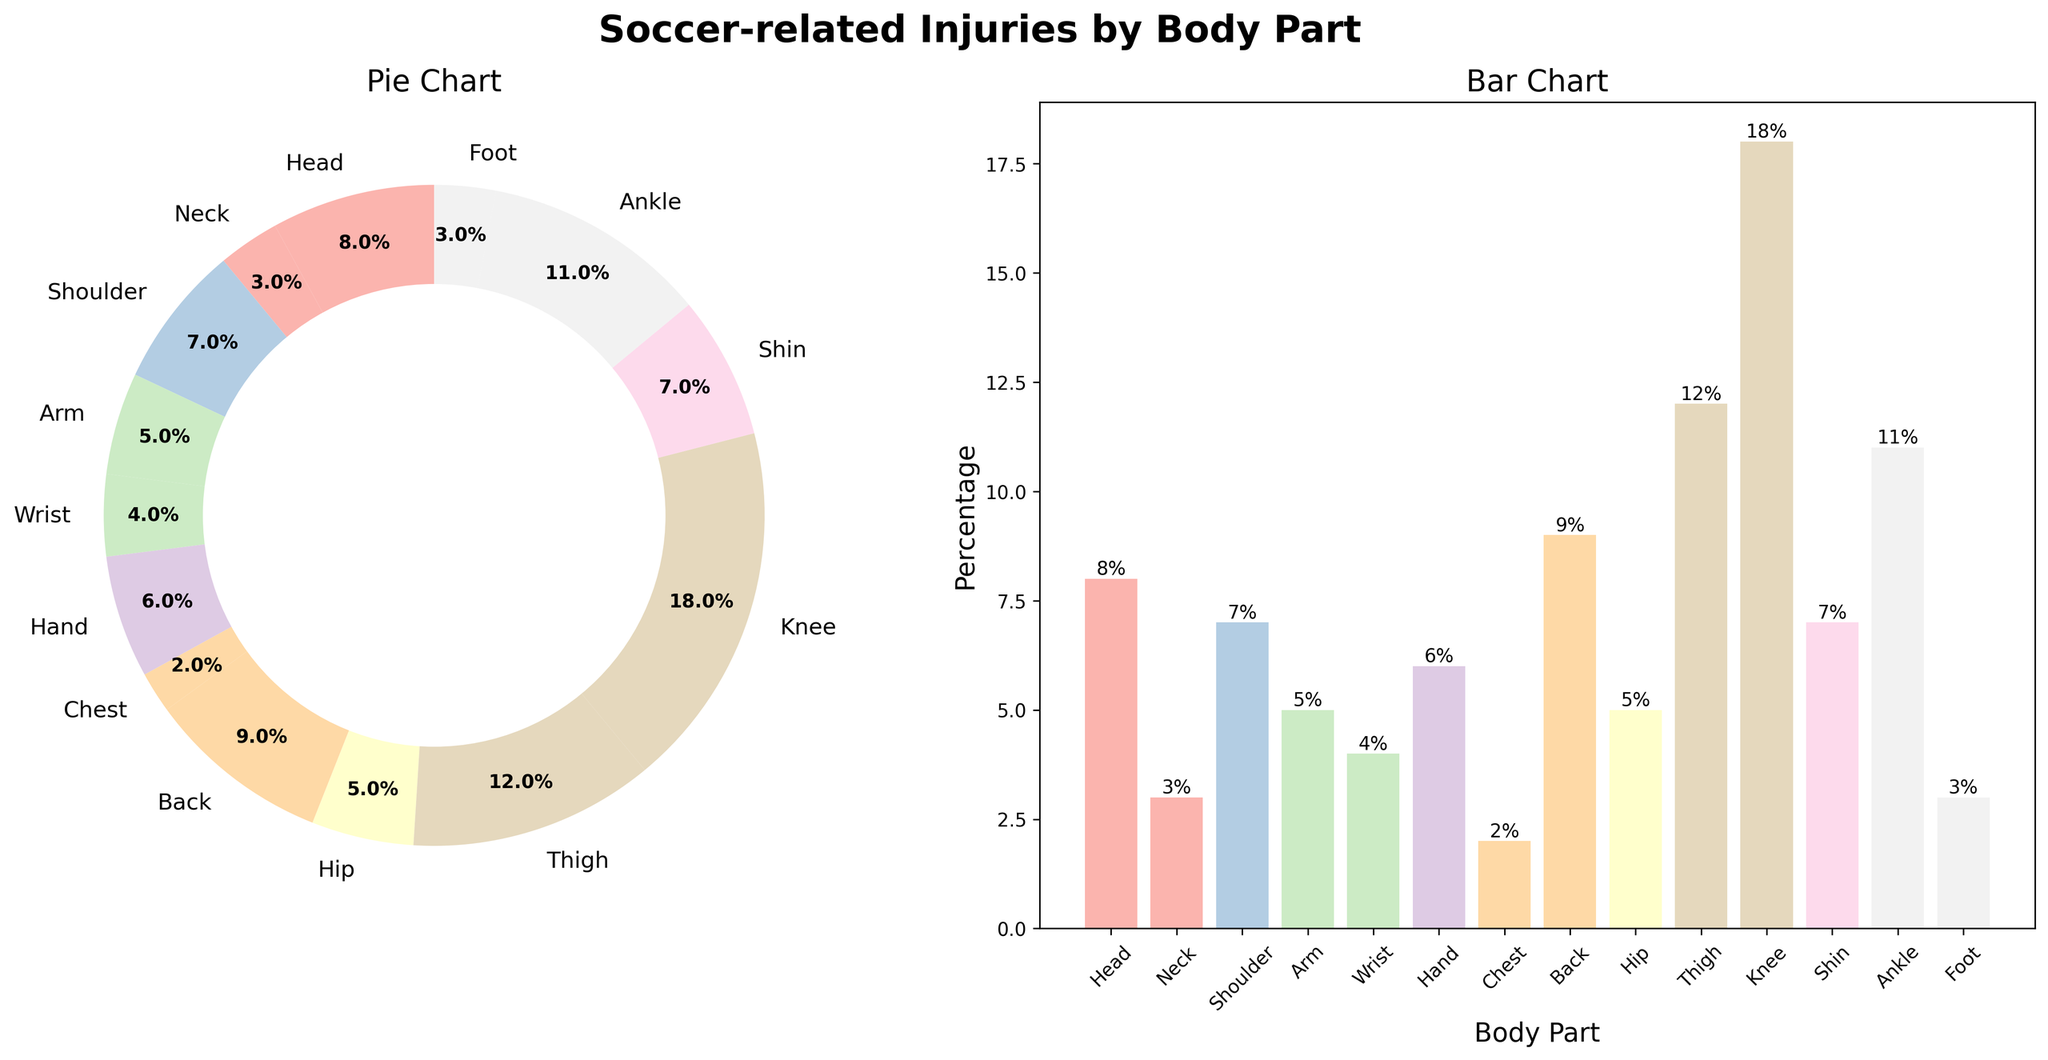What's the title of the figure? The title of the figure is written at the top and reads "Soccer-related Injuries by Body Part."
Answer: Soccer-related Injuries by Body Part Which body part has the highest percentage of injuries? Looking at both the pie chart and the bar chart, the body part with the highest percentage of injuries is the knee, which is labeled with 18%.
Answer: Knee What percentage of injuries occur in the ankle? Both the pie chart and the bar chart show that the ankle accounts for 11% of the injuries.
Answer: 11% What are the three body parts with the lowest percentages of injuries? Observing the bar chart, the three body parts with the lowest percentages of injuries are the chest (2%), neck (3%), and foot (3%).
Answer: Chest, Neck, Foot Combine the percentages of injuries for the head, arm, and hand. What is the total? The head has 8%, the arm has 5%, and the hand has 6%. Adding these together: 8% + 5% + 6% = 19%.
Answer: 19% What is the difference in percentage between knee and thigh injuries? The knee has 18% injuries and the thigh has 12% injuries. The difference is 18% - 12% = 6%.
Answer: 6% Which body part has a greater percentage of injuries: the back or the shoulder? The bar chart shows the back with 9% and the shoulder with 7%. 9% is greater than 7%, so the back has the greater percentage of injuries.
Answer: Back How many body parts have an injury percentage greater than 10%? From the bar chart, we see that there are two body parts with an injury percentage greater than 10%: knee (18%) and thigh (12%).
Answer: 2 Which chart type (pie or bar) makes it easier to compare individual body part percentages? The bar chart typically makes it easier to compare individual body part percentages as the heights of bars can be compared directly.
Answer: Bar chart If the total percentage for all body parts needs to be checked, does the pie chart visually indicate that? A pie chart represents the whole as 100%, and each segment visually indicates its proportion of that total, making it easy to verify the completeness of data.
Answer: Yes 